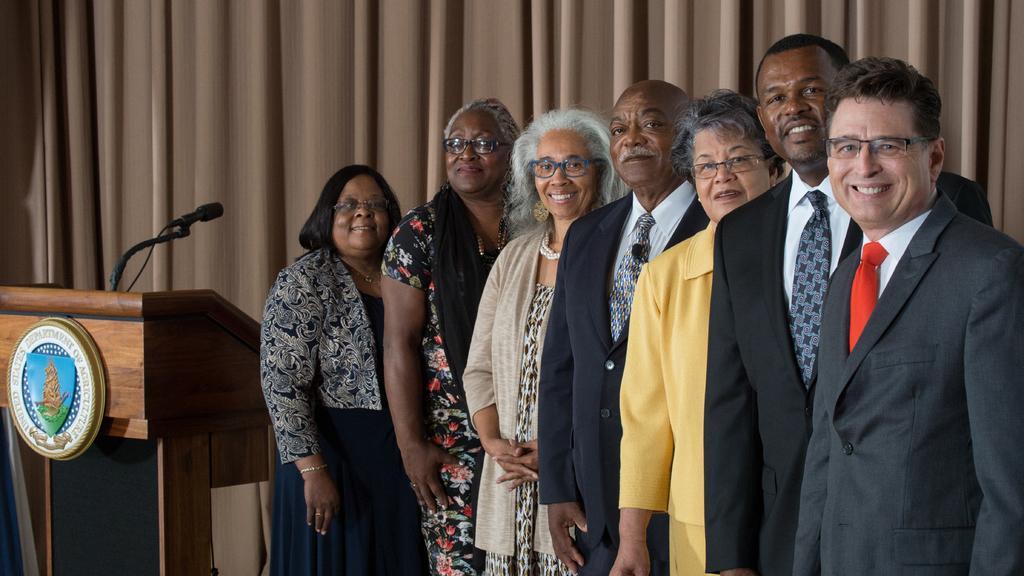How would you summarize this image in a sentence or two? In this image I can see few persons are standing beside each other and smiling. I can see few of them are wearing spectacles. In the background I can see a brown colored podium, a microphone and the brown colored curtain. 